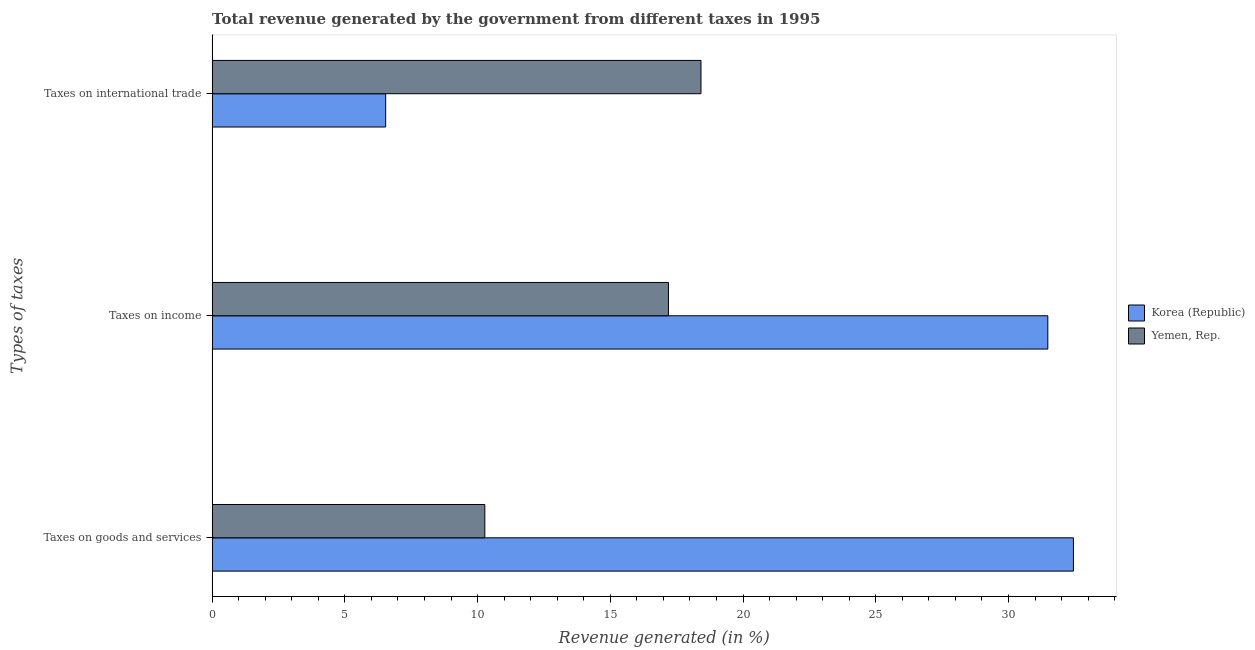How many different coloured bars are there?
Your answer should be very brief. 2. What is the label of the 3rd group of bars from the top?
Ensure brevity in your answer.  Taxes on goods and services. What is the percentage of revenue generated by tax on international trade in Yemen, Rep.?
Ensure brevity in your answer.  18.42. Across all countries, what is the maximum percentage of revenue generated by tax on international trade?
Offer a terse response. 18.42. Across all countries, what is the minimum percentage of revenue generated by tax on international trade?
Provide a succinct answer. 6.54. In which country was the percentage of revenue generated by taxes on income maximum?
Your response must be concise. Korea (Republic). In which country was the percentage of revenue generated by taxes on income minimum?
Keep it short and to the point. Yemen, Rep. What is the total percentage of revenue generated by taxes on goods and services in the graph?
Keep it short and to the point. 42.72. What is the difference between the percentage of revenue generated by taxes on income in Yemen, Rep. and that in Korea (Republic)?
Make the answer very short. -14.29. What is the difference between the percentage of revenue generated by taxes on goods and services in Yemen, Rep. and the percentage of revenue generated by tax on international trade in Korea (Republic)?
Give a very brief answer. 3.74. What is the average percentage of revenue generated by taxes on goods and services per country?
Make the answer very short. 21.36. What is the difference between the percentage of revenue generated by taxes on goods and services and percentage of revenue generated by taxes on income in Korea (Republic)?
Your answer should be very brief. 0.97. In how many countries, is the percentage of revenue generated by taxes on income greater than 8 %?
Offer a very short reply. 2. What is the ratio of the percentage of revenue generated by taxes on income in Korea (Republic) to that in Yemen, Rep.?
Your answer should be very brief. 1.83. Is the percentage of revenue generated by tax on international trade in Korea (Republic) less than that in Yemen, Rep.?
Ensure brevity in your answer.  Yes. Is the difference between the percentage of revenue generated by taxes on income in Korea (Republic) and Yemen, Rep. greater than the difference between the percentage of revenue generated by tax on international trade in Korea (Republic) and Yemen, Rep.?
Give a very brief answer. Yes. What is the difference between the highest and the second highest percentage of revenue generated by taxes on income?
Offer a terse response. 14.29. What is the difference between the highest and the lowest percentage of revenue generated by taxes on income?
Give a very brief answer. 14.29. Is the sum of the percentage of revenue generated by taxes on income in Korea (Republic) and Yemen, Rep. greater than the maximum percentage of revenue generated by tax on international trade across all countries?
Make the answer very short. Yes. What does the 1st bar from the bottom in Taxes on income represents?
Ensure brevity in your answer.  Korea (Republic). Is it the case that in every country, the sum of the percentage of revenue generated by taxes on goods and services and percentage of revenue generated by taxes on income is greater than the percentage of revenue generated by tax on international trade?
Make the answer very short. Yes. How many bars are there?
Offer a very short reply. 6. Are all the bars in the graph horizontal?
Provide a short and direct response. Yes. What is the difference between two consecutive major ticks on the X-axis?
Offer a terse response. 5. Does the graph contain any zero values?
Make the answer very short. No. Does the graph contain grids?
Your response must be concise. No. Where does the legend appear in the graph?
Your answer should be compact. Center right. How many legend labels are there?
Offer a terse response. 2. How are the legend labels stacked?
Your response must be concise. Vertical. What is the title of the graph?
Ensure brevity in your answer.  Total revenue generated by the government from different taxes in 1995. What is the label or title of the X-axis?
Your response must be concise. Revenue generated (in %). What is the label or title of the Y-axis?
Offer a terse response. Types of taxes. What is the Revenue generated (in %) in Korea (Republic) in Taxes on goods and services?
Give a very brief answer. 32.45. What is the Revenue generated (in %) of Yemen, Rep. in Taxes on goods and services?
Your answer should be very brief. 10.27. What is the Revenue generated (in %) of Korea (Republic) in Taxes on income?
Provide a succinct answer. 31.48. What is the Revenue generated (in %) in Yemen, Rep. in Taxes on income?
Make the answer very short. 17.19. What is the Revenue generated (in %) of Korea (Republic) in Taxes on international trade?
Offer a terse response. 6.54. What is the Revenue generated (in %) in Yemen, Rep. in Taxes on international trade?
Make the answer very short. 18.42. Across all Types of taxes, what is the maximum Revenue generated (in %) of Korea (Republic)?
Provide a succinct answer. 32.45. Across all Types of taxes, what is the maximum Revenue generated (in %) in Yemen, Rep.?
Provide a succinct answer. 18.42. Across all Types of taxes, what is the minimum Revenue generated (in %) of Korea (Republic)?
Give a very brief answer. 6.54. Across all Types of taxes, what is the minimum Revenue generated (in %) in Yemen, Rep.?
Keep it short and to the point. 10.27. What is the total Revenue generated (in %) in Korea (Republic) in the graph?
Your answer should be very brief. 70.47. What is the total Revenue generated (in %) of Yemen, Rep. in the graph?
Your response must be concise. 45.88. What is the difference between the Revenue generated (in %) of Korea (Republic) in Taxes on goods and services and that in Taxes on income?
Offer a very short reply. 0.97. What is the difference between the Revenue generated (in %) in Yemen, Rep. in Taxes on goods and services and that in Taxes on income?
Provide a short and direct response. -6.92. What is the difference between the Revenue generated (in %) in Korea (Republic) in Taxes on goods and services and that in Taxes on international trade?
Your answer should be very brief. 25.91. What is the difference between the Revenue generated (in %) of Yemen, Rep. in Taxes on goods and services and that in Taxes on international trade?
Provide a short and direct response. -8.14. What is the difference between the Revenue generated (in %) in Korea (Republic) in Taxes on income and that in Taxes on international trade?
Your answer should be very brief. 24.94. What is the difference between the Revenue generated (in %) in Yemen, Rep. in Taxes on income and that in Taxes on international trade?
Your answer should be very brief. -1.23. What is the difference between the Revenue generated (in %) of Korea (Republic) in Taxes on goods and services and the Revenue generated (in %) of Yemen, Rep. in Taxes on income?
Ensure brevity in your answer.  15.26. What is the difference between the Revenue generated (in %) of Korea (Republic) in Taxes on goods and services and the Revenue generated (in %) of Yemen, Rep. in Taxes on international trade?
Your answer should be compact. 14.03. What is the difference between the Revenue generated (in %) of Korea (Republic) in Taxes on income and the Revenue generated (in %) of Yemen, Rep. in Taxes on international trade?
Offer a very short reply. 13.07. What is the average Revenue generated (in %) in Korea (Republic) per Types of taxes?
Your answer should be compact. 23.49. What is the average Revenue generated (in %) of Yemen, Rep. per Types of taxes?
Give a very brief answer. 15.29. What is the difference between the Revenue generated (in %) of Korea (Republic) and Revenue generated (in %) of Yemen, Rep. in Taxes on goods and services?
Your answer should be compact. 22.17. What is the difference between the Revenue generated (in %) in Korea (Republic) and Revenue generated (in %) in Yemen, Rep. in Taxes on income?
Your response must be concise. 14.29. What is the difference between the Revenue generated (in %) of Korea (Republic) and Revenue generated (in %) of Yemen, Rep. in Taxes on international trade?
Provide a succinct answer. -11.88. What is the ratio of the Revenue generated (in %) in Korea (Republic) in Taxes on goods and services to that in Taxes on income?
Provide a short and direct response. 1.03. What is the ratio of the Revenue generated (in %) of Yemen, Rep. in Taxes on goods and services to that in Taxes on income?
Your response must be concise. 0.6. What is the ratio of the Revenue generated (in %) in Korea (Republic) in Taxes on goods and services to that in Taxes on international trade?
Your answer should be compact. 4.96. What is the ratio of the Revenue generated (in %) of Yemen, Rep. in Taxes on goods and services to that in Taxes on international trade?
Provide a succinct answer. 0.56. What is the ratio of the Revenue generated (in %) of Korea (Republic) in Taxes on income to that in Taxes on international trade?
Ensure brevity in your answer.  4.82. What is the ratio of the Revenue generated (in %) in Yemen, Rep. in Taxes on income to that in Taxes on international trade?
Keep it short and to the point. 0.93. What is the difference between the highest and the second highest Revenue generated (in %) in Korea (Republic)?
Give a very brief answer. 0.97. What is the difference between the highest and the second highest Revenue generated (in %) in Yemen, Rep.?
Keep it short and to the point. 1.23. What is the difference between the highest and the lowest Revenue generated (in %) of Korea (Republic)?
Provide a succinct answer. 25.91. What is the difference between the highest and the lowest Revenue generated (in %) in Yemen, Rep.?
Offer a very short reply. 8.14. 